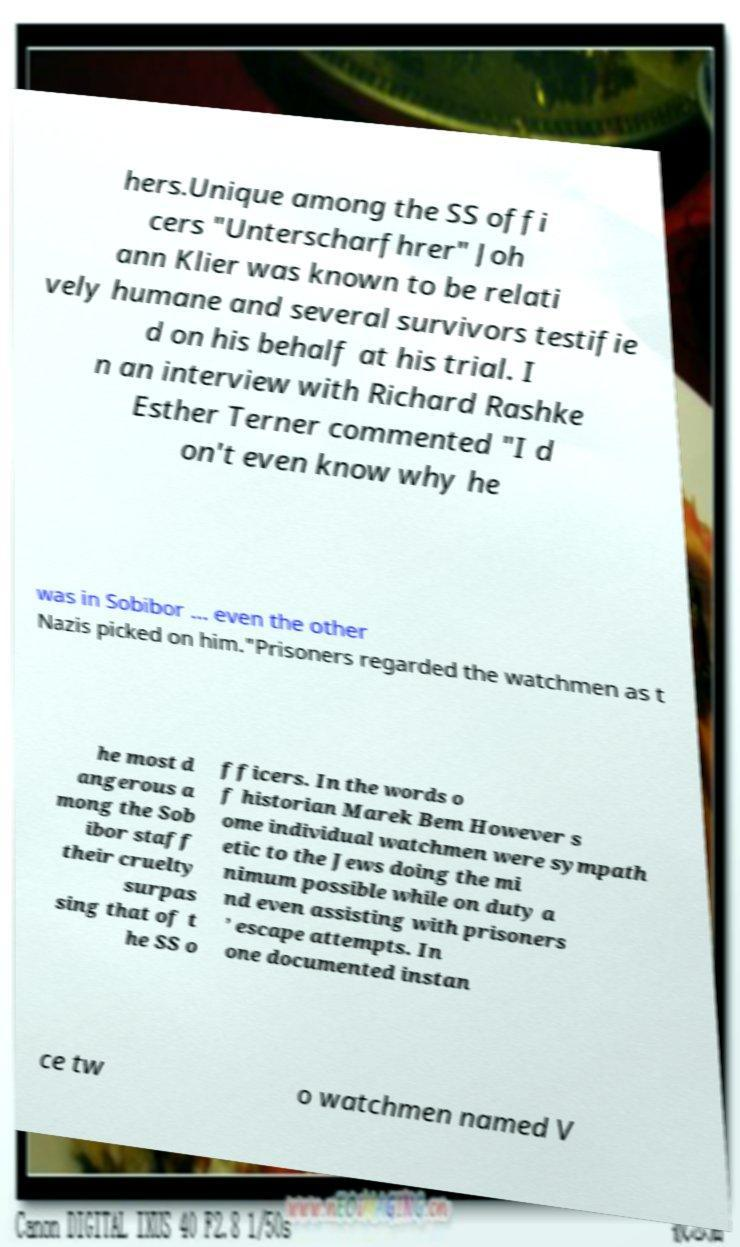Could you extract and type out the text from this image? hers.Unique among the SS offi cers "Unterscharfhrer" Joh ann Klier was known to be relati vely humane and several survivors testifie d on his behalf at his trial. I n an interview with Richard Rashke Esther Terner commented "I d on't even know why he was in Sobibor ... even the other Nazis picked on him."Prisoners regarded the watchmen as t he most d angerous a mong the Sob ibor staff their cruelty surpas sing that of t he SS o fficers. In the words o f historian Marek Bem However s ome individual watchmen were sympath etic to the Jews doing the mi nimum possible while on duty a nd even assisting with prisoners ’ escape attempts. In one documented instan ce tw o watchmen named V 